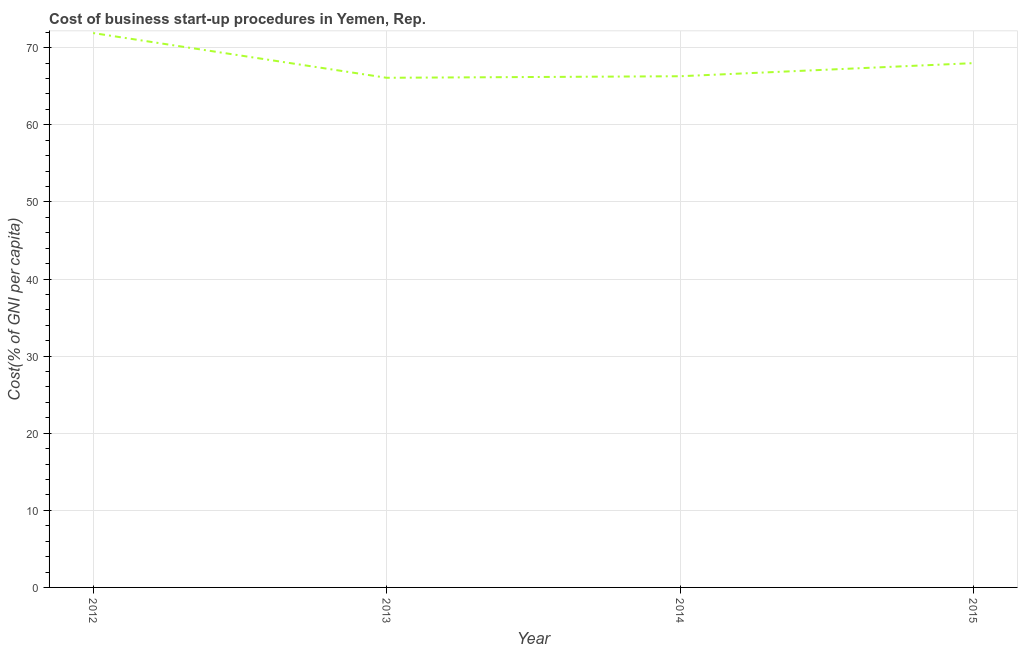Across all years, what is the maximum cost of business startup procedures?
Make the answer very short. 71.9. Across all years, what is the minimum cost of business startup procedures?
Offer a very short reply. 66.1. In which year was the cost of business startup procedures minimum?
Provide a succinct answer. 2013. What is the sum of the cost of business startup procedures?
Your answer should be very brief. 272.3. What is the difference between the cost of business startup procedures in 2012 and 2014?
Your answer should be compact. 5.6. What is the average cost of business startup procedures per year?
Your response must be concise. 68.08. What is the median cost of business startup procedures?
Provide a short and direct response. 67.15. Is the cost of business startup procedures in 2013 less than that in 2014?
Provide a short and direct response. Yes. What is the difference between the highest and the second highest cost of business startup procedures?
Keep it short and to the point. 3.9. What is the difference between the highest and the lowest cost of business startup procedures?
Provide a short and direct response. 5.8. Does the cost of business startup procedures monotonically increase over the years?
Offer a very short reply. No. How many lines are there?
Keep it short and to the point. 1. How many years are there in the graph?
Ensure brevity in your answer.  4. What is the difference between two consecutive major ticks on the Y-axis?
Provide a succinct answer. 10. Are the values on the major ticks of Y-axis written in scientific E-notation?
Your answer should be very brief. No. What is the title of the graph?
Keep it short and to the point. Cost of business start-up procedures in Yemen, Rep. What is the label or title of the Y-axis?
Make the answer very short. Cost(% of GNI per capita). What is the Cost(% of GNI per capita) in 2012?
Your response must be concise. 71.9. What is the Cost(% of GNI per capita) of 2013?
Your answer should be compact. 66.1. What is the Cost(% of GNI per capita) in 2014?
Your answer should be very brief. 66.3. What is the difference between the Cost(% of GNI per capita) in 2012 and 2014?
Your answer should be compact. 5.6. What is the difference between the Cost(% of GNI per capita) in 2013 and 2014?
Offer a very short reply. -0.2. What is the difference between the Cost(% of GNI per capita) in 2014 and 2015?
Your answer should be compact. -1.7. What is the ratio of the Cost(% of GNI per capita) in 2012 to that in 2013?
Your response must be concise. 1.09. What is the ratio of the Cost(% of GNI per capita) in 2012 to that in 2014?
Ensure brevity in your answer.  1.08. What is the ratio of the Cost(% of GNI per capita) in 2012 to that in 2015?
Give a very brief answer. 1.06. What is the ratio of the Cost(% of GNI per capita) in 2013 to that in 2014?
Provide a succinct answer. 1. 